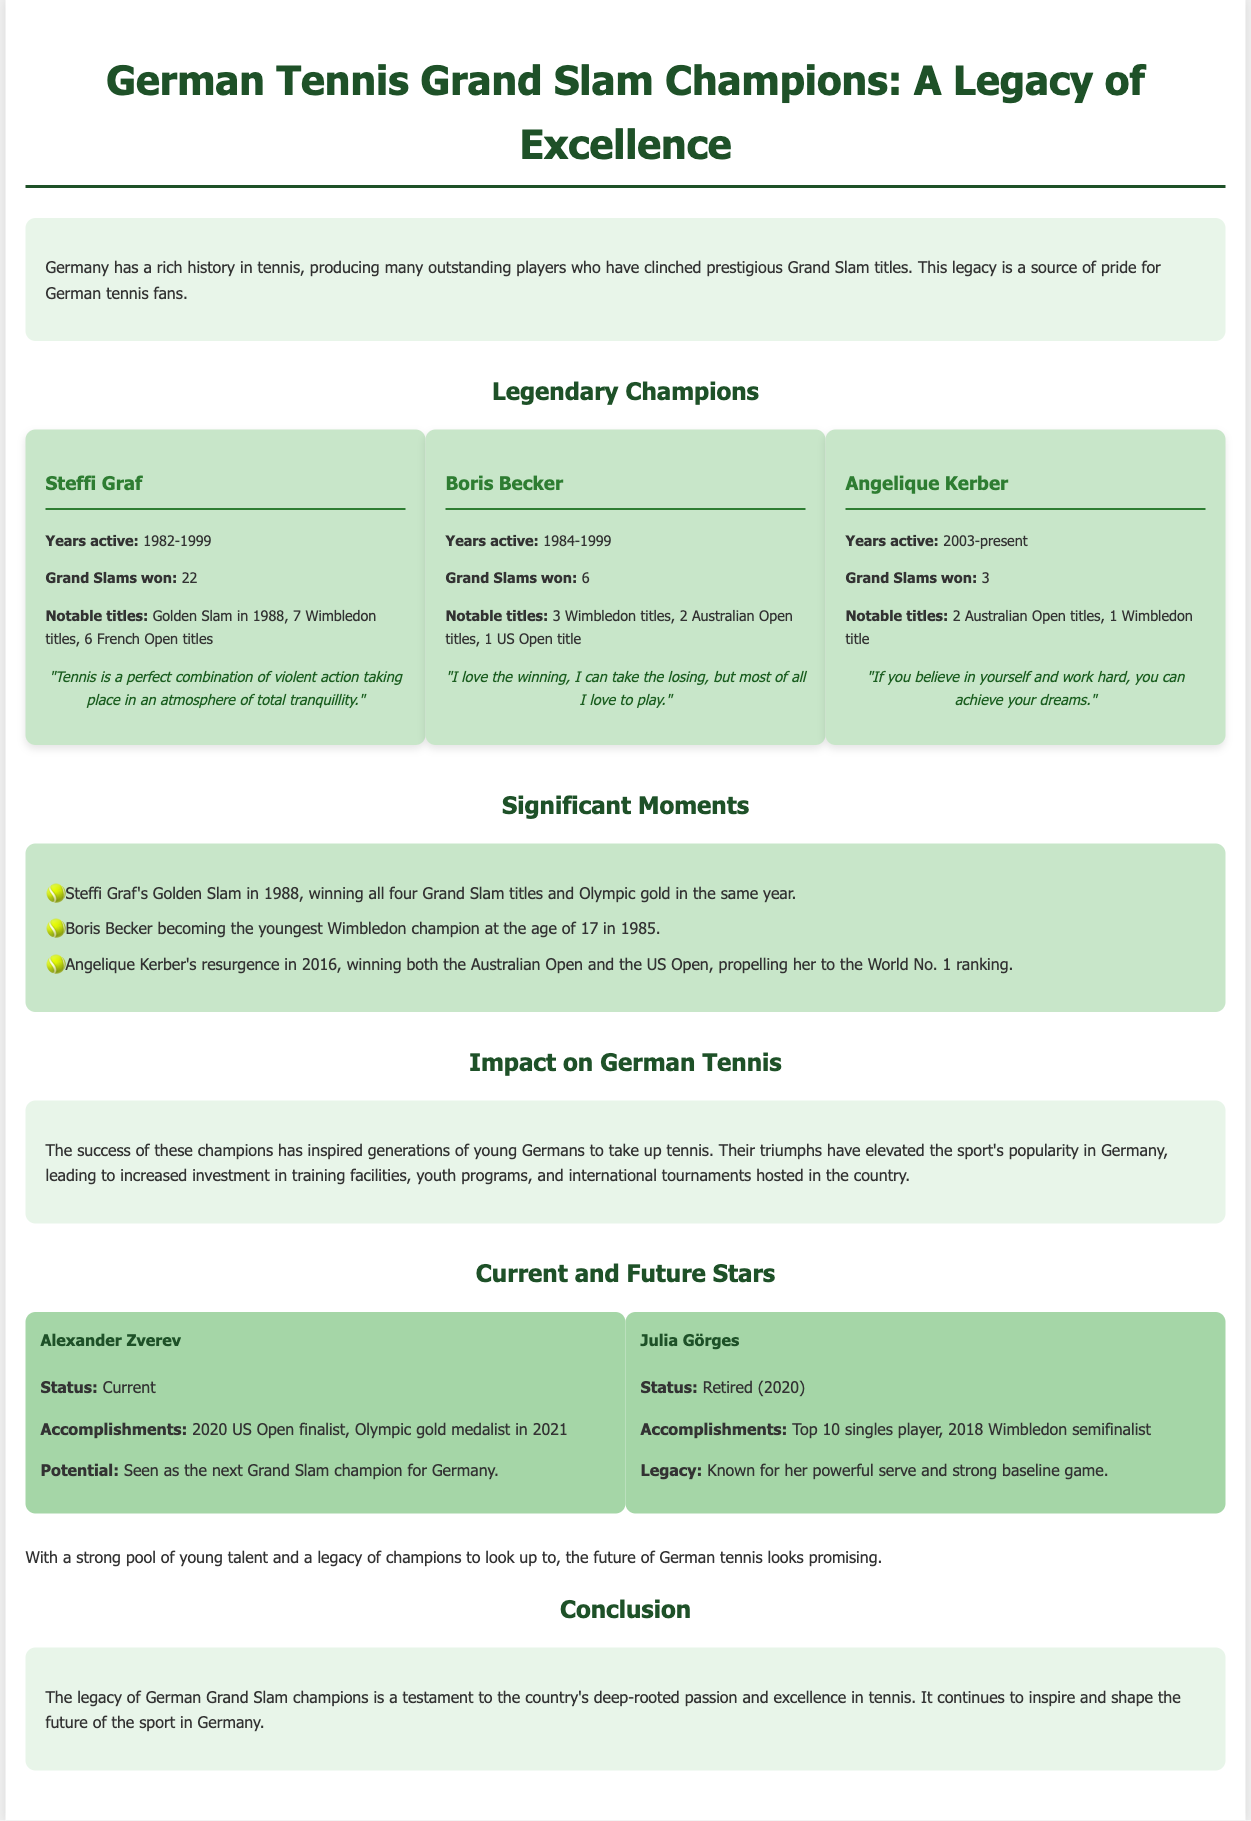What is the total number of Grand Slams won by Steffi Graf? The document states that Steffi Graf won 22 Grand Slams, which is specified under her achievements.
Answer: 22 How many Wimbledon titles did Boris Becker win? The document mentions that Boris Becker won 3 Wimbledon titles in the section detailing his notable achievements.
Answer: 3 Which German tennis player achieved a Golden Slam? The infographic notes that Steffi Graf achieved a Golden Slam in 1988, highlighting this significant moment in her career.
Answer: Steffi Graf What years was Angelique Kerber active as a professional player? The document lists Angelique Kerber's years active as 2003 to present, providing a specific timeframe for her career.
Answer: 2003-present Who was the youngest Wimbledon champion and at what age? The document states that Boris Becker became the youngest Wimbledon champion at the age of 17 in 1985.
Answer: 17 What significant achievement did Alexander Zverev accomplish in 2021? The document highlights that Alexander Zverev won the Olympic gold medal in 2021, showcasing his accomplishments.
Answer: Olympic gold medalist How many Grand Slam titles has Angelique Kerber won? The document specifies that Angelique Kerber has won 3 Grand Slam titles, answering the question directly.
Answer: 3 What impact did these champions have on German tennis? The document discusses how the success of these champions has inspired generations of young Germans to take up tennis.
Answer: Inspired young Germans What is the legacy of German Grand Slam champions? The document concludes that the legacy is a testament to the country's passion and excellence in tennis, shaping the future of the sport.
Answer: Passion and excellence 